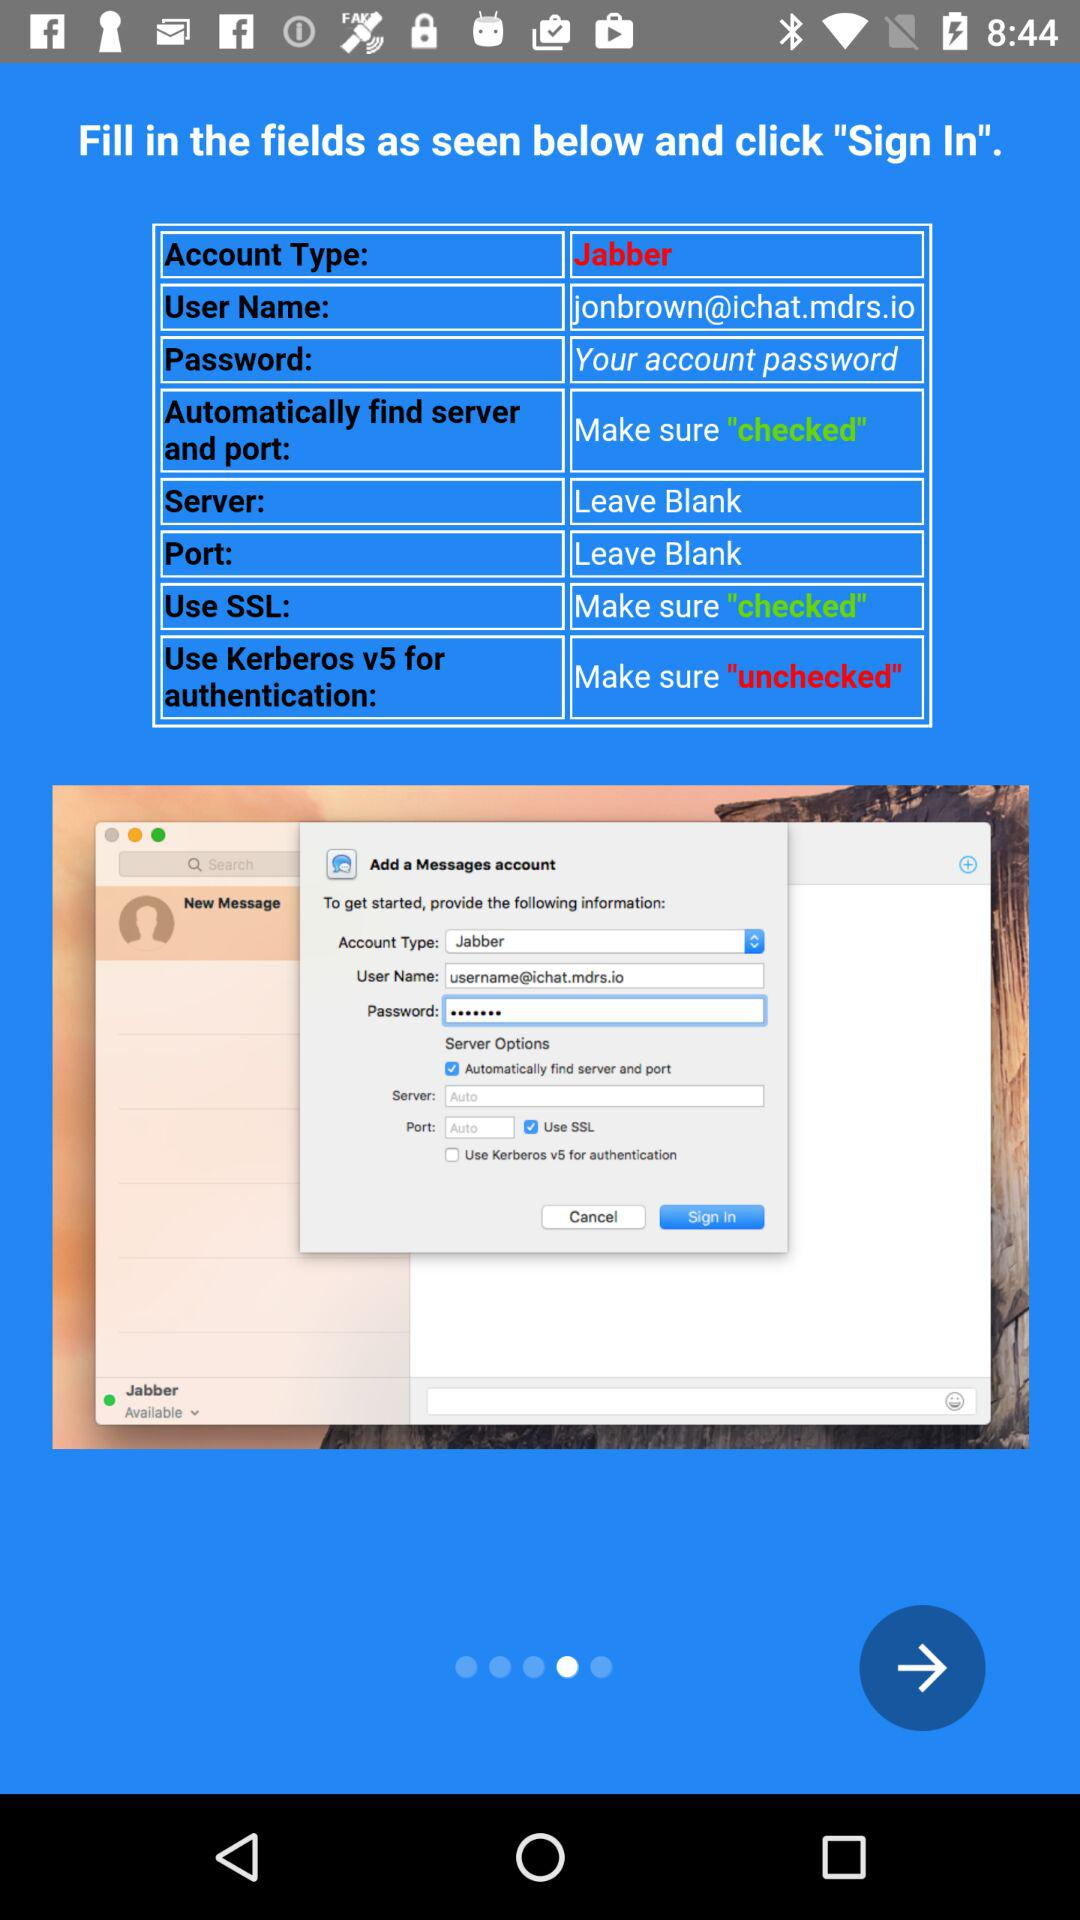What is the account type? The account type is Jabber. 